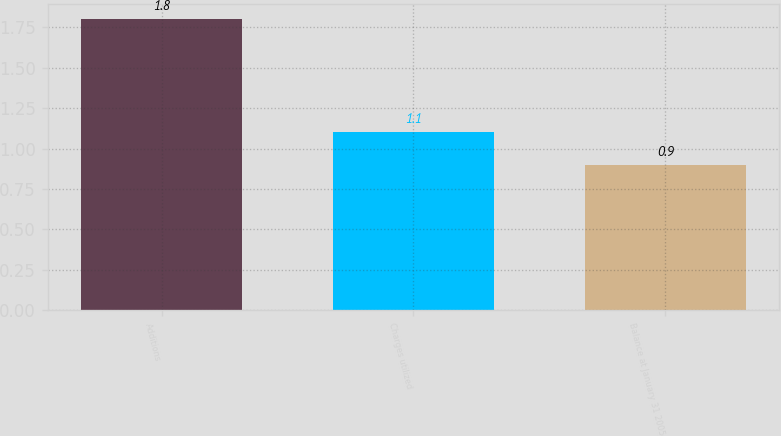Convert chart. <chart><loc_0><loc_0><loc_500><loc_500><bar_chart><fcel>Additions<fcel>Charges utilized<fcel>Balance at January 31 2005<nl><fcel>1.8<fcel>1.1<fcel>0.9<nl></chart> 